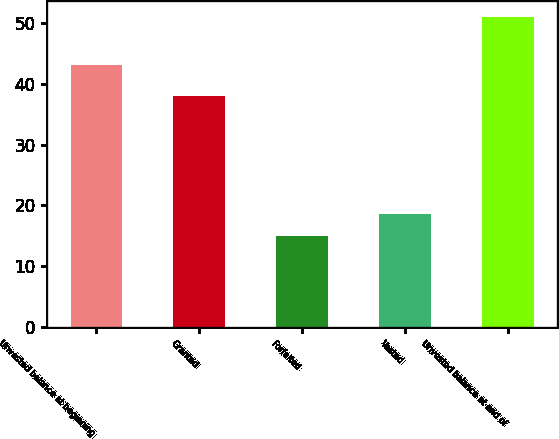<chart> <loc_0><loc_0><loc_500><loc_500><bar_chart><fcel>Unvested balance at beginning<fcel>Granted<fcel>Forfeited<fcel>Vested<fcel>Unvested balance at end of<nl><fcel>43<fcel>38<fcel>15<fcel>18.6<fcel>51<nl></chart> 